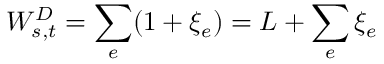Convert formula to latex. <formula><loc_0><loc_0><loc_500><loc_500>W _ { s , t } ^ { D } = \sum _ { e } ( 1 + \xi _ { e } ) = L + \sum _ { e } \xi _ { e }</formula> 